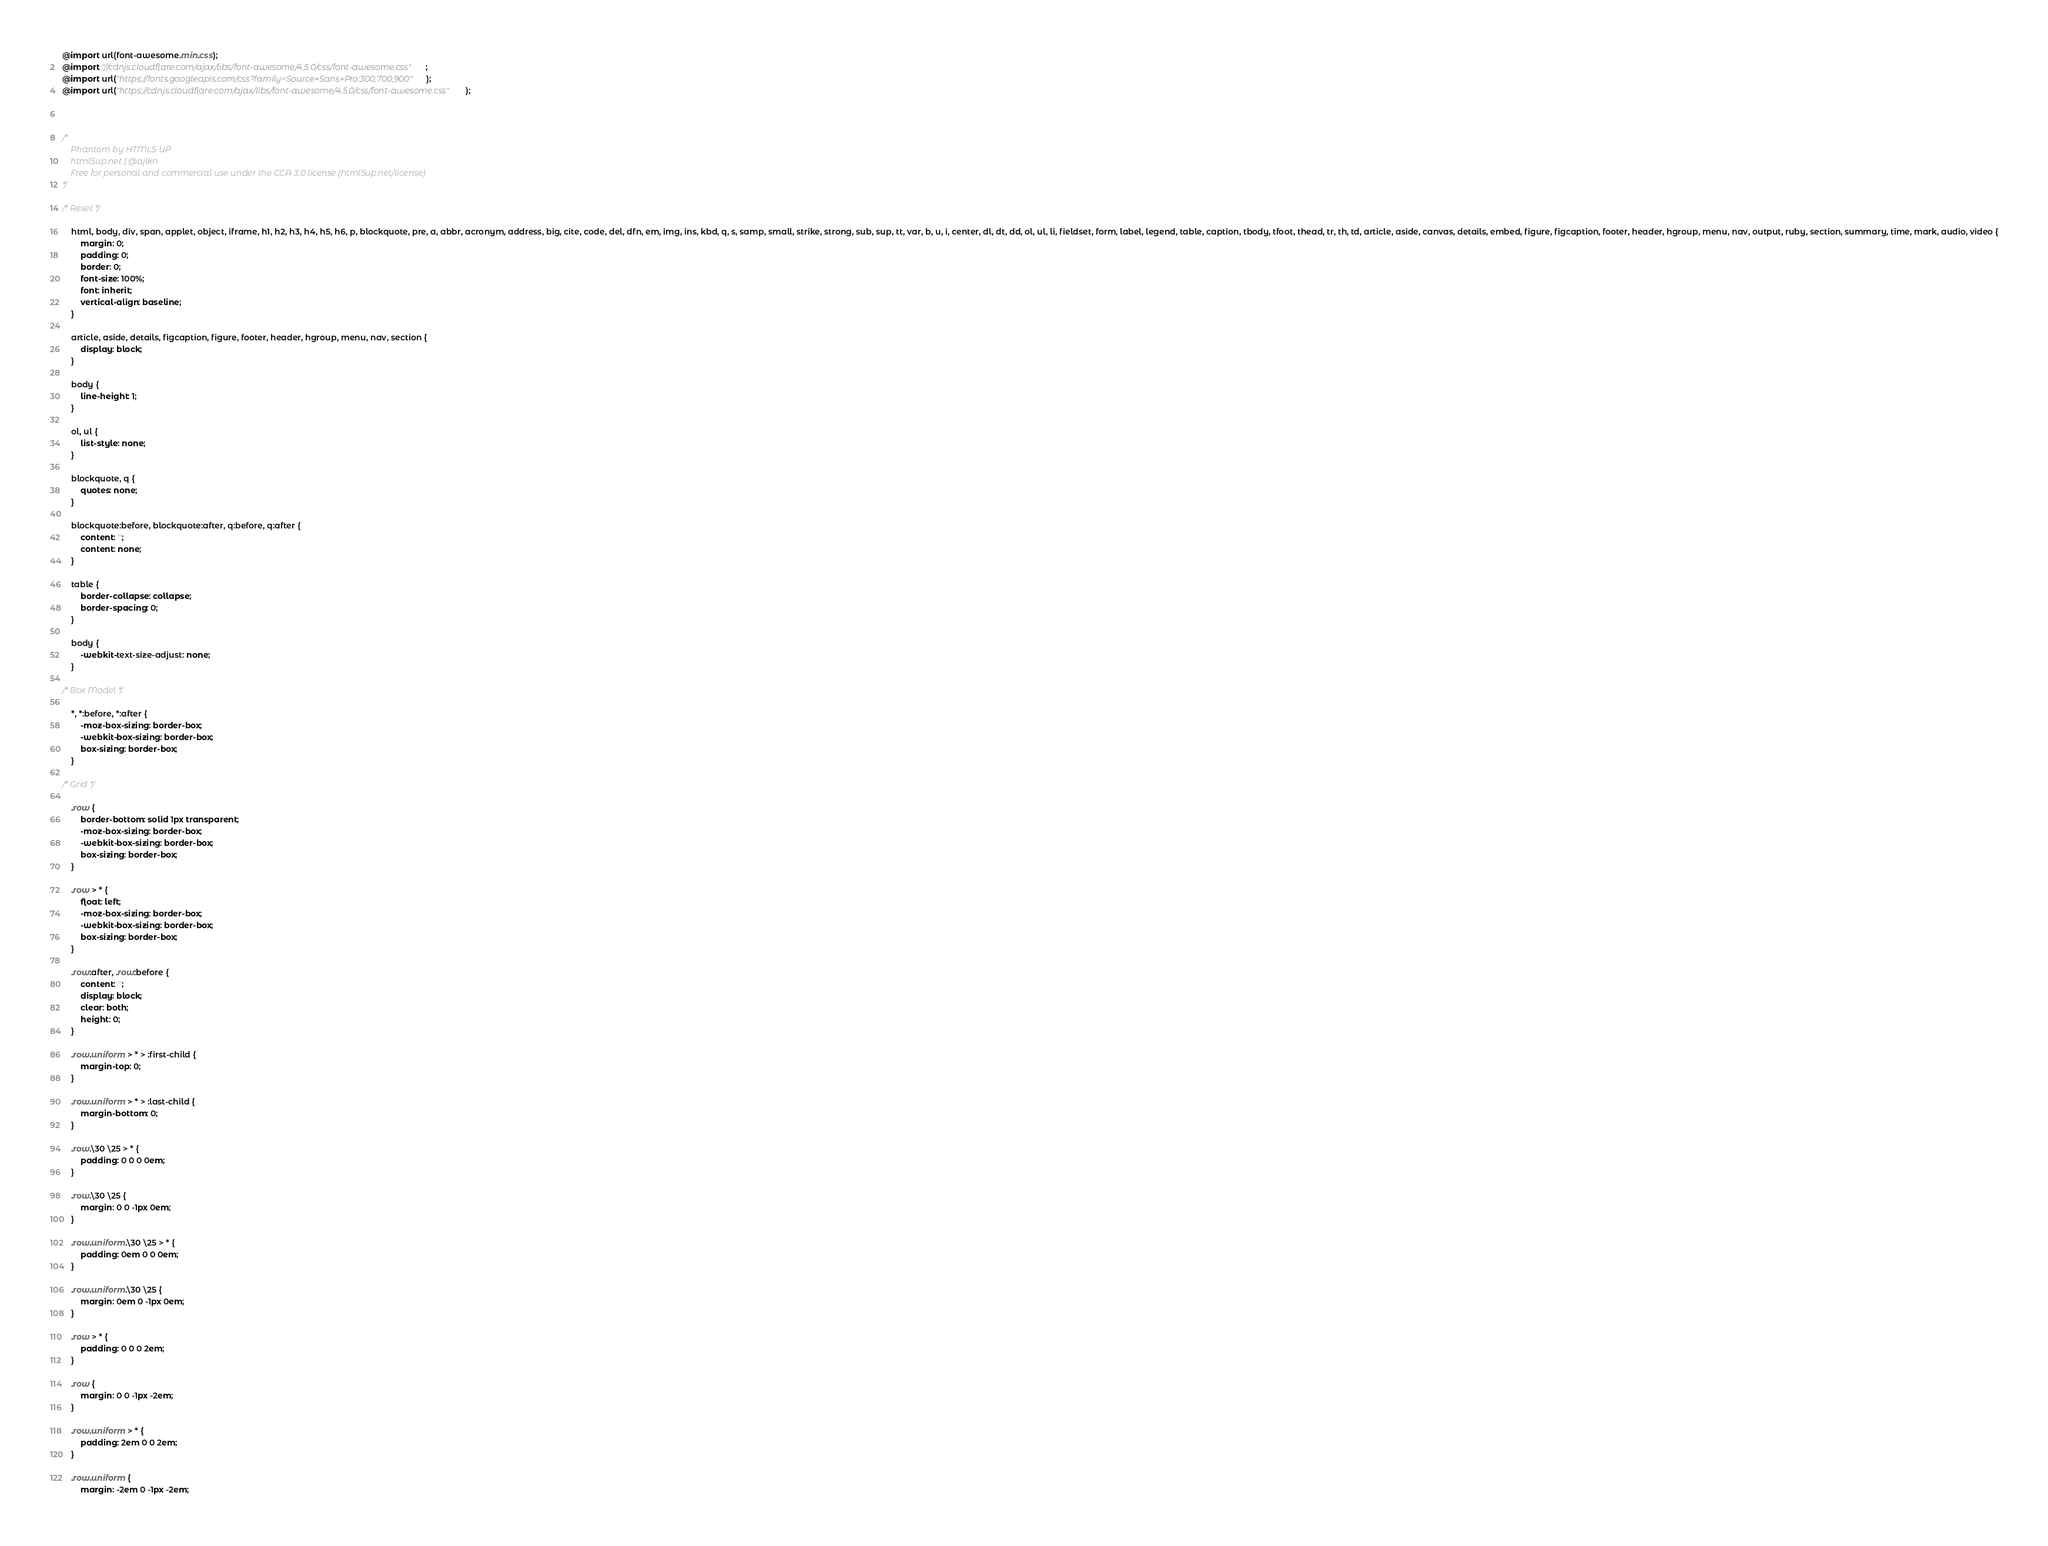<code> <loc_0><loc_0><loc_500><loc_500><_CSS_>@import url(font-awesome.min.css);
@import "//cdnjs.cloudflare.com/ajax/libs/font-awesome/4.5.0/css/font-awesome.css";
@import url("https://fonts.googleapis.com/css?family=Source+Sans+Pro:300,700,900");
@import url("https://cdnjs.cloudflare.com/ajax/libs/font-awesome/4.5.0/css/font-awesome.css");



/*
	Phantom by HTML5 UP
	html5up.net | @ajlkn
	Free for personal and commercial use under the CCA 3.0 license (html5up.net/license)
*/

/* Reset */

	html, body, div, span, applet, object, iframe, h1, h2, h3, h4, h5, h6, p, blockquote, pre, a, abbr, acronym, address, big, cite, code, del, dfn, em, img, ins, kbd, q, s, samp, small, strike, strong, sub, sup, tt, var, b, u, i, center, dl, dt, dd, ol, ul, li, fieldset, form, label, legend, table, caption, tbody, tfoot, thead, tr, th, td, article, aside, canvas, details, embed, figure, figcaption, footer, header, hgroup, menu, nav, output, ruby, section, summary, time, mark, audio, video {
		margin: 0;
		padding: 0;
		border: 0;
		font-size: 100%;
		font: inherit;
		vertical-align: baseline;
	}

	article, aside, details, figcaption, figure, footer, header, hgroup, menu, nav, section {
		display: block;
	}

	body {
		line-height: 1;
	}

	ol, ul {
		list-style: none;
	}

	blockquote, q {
		quotes: none;
	}

	blockquote:before, blockquote:after, q:before, q:after {
		content: '';
		content: none;
	}

	table {
		border-collapse: collapse;
		border-spacing: 0;
	}

	body {
		-webkit-text-size-adjust: none;
	}

/* Box Model */

	*, *:before, *:after {
		-moz-box-sizing: border-box;
		-webkit-box-sizing: border-box;
		box-sizing: border-box;
	}

/* Grid */

	.row {
		border-bottom: solid 1px transparent;
		-moz-box-sizing: border-box;
		-webkit-box-sizing: border-box;
		box-sizing: border-box;
	}

	.row > * {
		float: left;
		-moz-box-sizing: border-box;
		-webkit-box-sizing: border-box;
		box-sizing: border-box;
	}

	.row:after, .row:before {
		content: '';
		display: block;
		clear: both;
		height: 0;
	}

	.row.uniform > * > :first-child {
		margin-top: 0;
	}

	.row.uniform > * > :last-child {
		margin-bottom: 0;
	}

	.row.\30 \25 > * {
		padding: 0 0 0 0em;
	}

	.row.\30 \25 {
		margin: 0 0 -1px 0em;
	}

	.row.uniform.\30 \25 > * {
		padding: 0em 0 0 0em;
	}

	.row.uniform.\30 \25 {
		margin: 0em 0 -1px 0em;
	}

	.row > * {
		padding: 0 0 0 2em;
	}

	.row {
		margin: 0 0 -1px -2em;
	}

	.row.uniform > * {
		padding: 2em 0 0 2em;
	}

	.row.uniform {
		margin: -2em 0 -1px -2em;</code> 